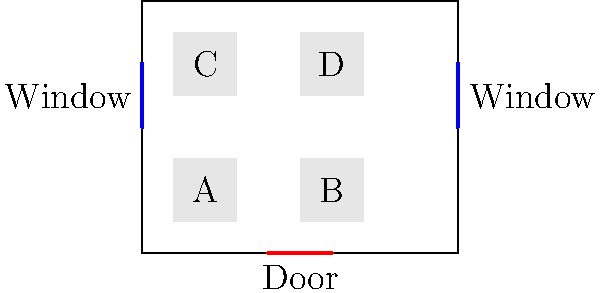Given the office layout shown above, which desk arrangement would be most ergonomically efficient for workers, considering natural light exposure, ease of movement, and proximity to the door? Justify your answer based on ergonomic principles and worker well-being. To determine the most ergonomically efficient desk arrangement, we need to consider several factors:

1. Natural light exposure: Natural light is essential for worker well-being and productivity. Desks near windows (A and C) have better access to natural light.

2. Ease of movement: Workers should have enough space to move around comfortably. The current arrangement allows for adequate movement between desks.

3. Proximity to the door: Easy access to exits is important for safety and convenience. Desks B and D are closer to the door.

4. Visual comfort: Workers should not face directly into windows to avoid glare. Desks A and C should be oriented perpendicular to the windows.

5. Collaborative spaces: The current arrangement allows for potential collaboration between desk pairs (A-B and C-D).

Considering these factors, the most ergonomically efficient arrangement would be:

- Keep desks A and C near the windows but rotate them 90 degrees to face the center of the room. This provides natural light without direct glare.
- Keep desks B and D in their current positions for easy access to the door.
- Ensure all desks have ergonomic chairs and proper equipment placement (monitors at eye level, keyboards at elbow height).

This arrangement maximizes natural light exposure, maintains ease of movement, provides quick access to the exit, and allows for collaboration while minimizing potential discomfort from glare.
Answer: Rotate desks A and C 90 degrees, facing room center; keep B and D as is. 